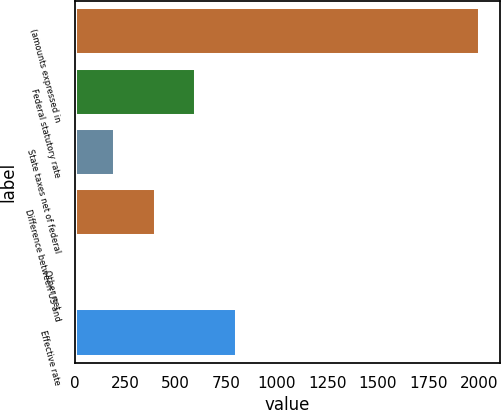Convert chart to OTSL. <chart><loc_0><loc_0><loc_500><loc_500><bar_chart><fcel>(amounts expressed in<fcel>Federal statutory rate<fcel>State taxes net of federal<fcel>Difference between US and<fcel>Other net<fcel>Effective rate<nl><fcel>2004<fcel>601.62<fcel>200.94<fcel>401.28<fcel>0.6<fcel>801.96<nl></chart> 